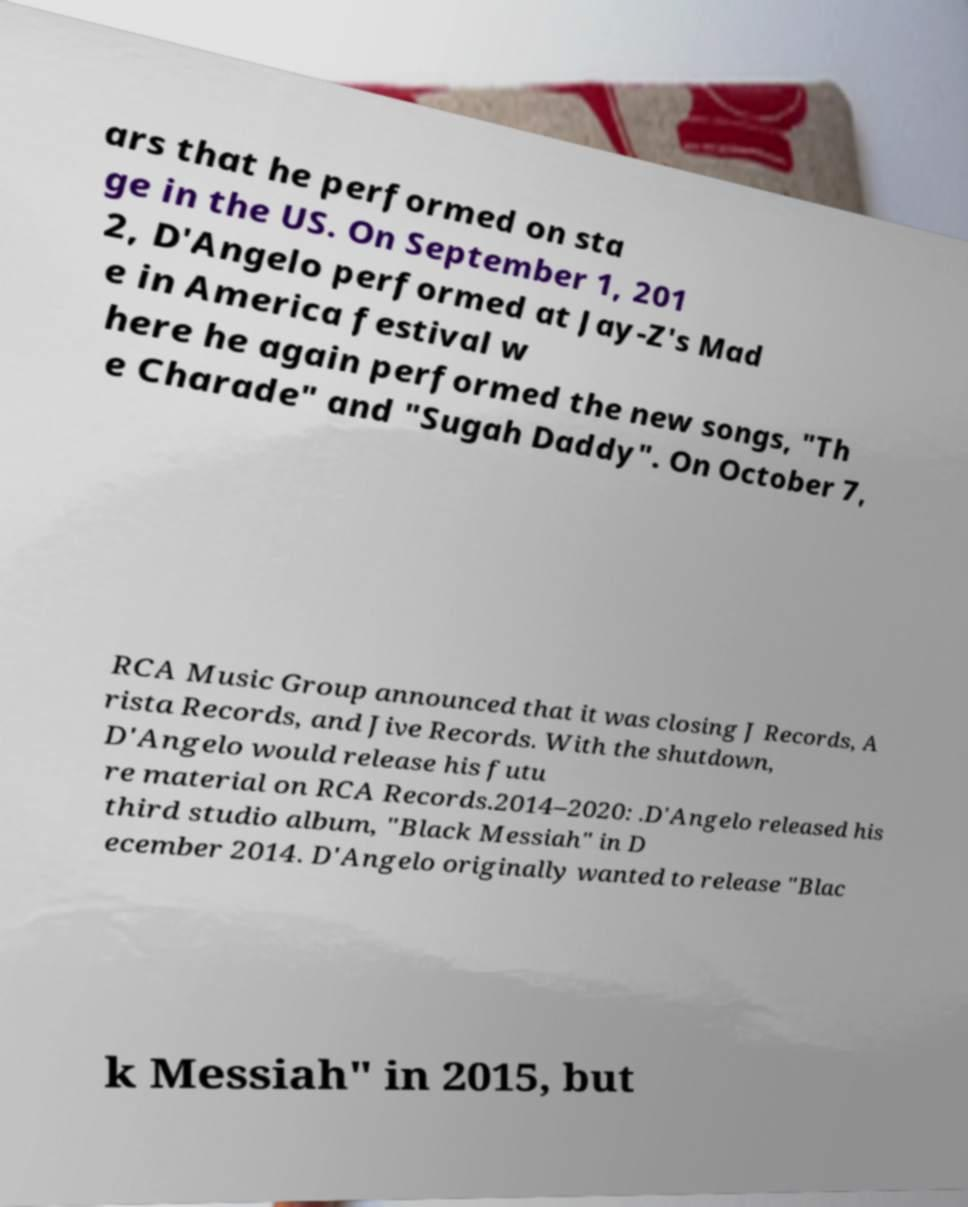There's text embedded in this image that I need extracted. Can you transcribe it verbatim? ars that he performed on sta ge in the US. On September 1, 201 2, D'Angelo performed at Jay-Z's Mad e in America festival w here he again performed the new songs, "Th e Charade" and "Sugah Daddy". On October 7, RCA Music Group announced that it was closing J Records, A rista Records, and Jive Records. With the shutdown, D'Angelo would release his futu re material on RCA Records.2014–2020: .D'Angelo released his third studio album, "Black Messiah" in D ecember 2014. D'Angelo originally wanted to release "Blac k Messiah" in 2015, but 